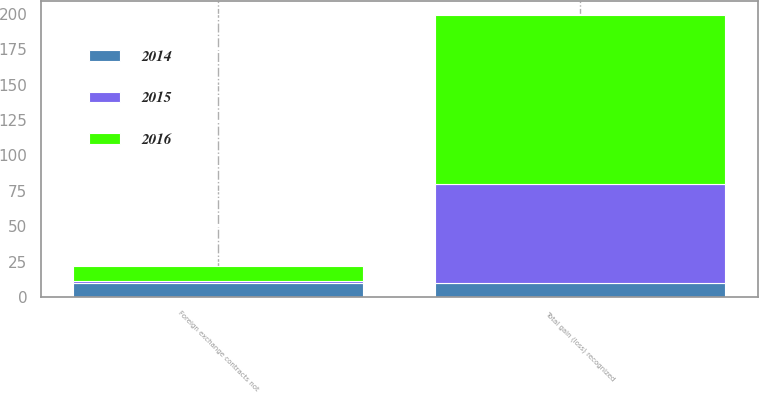<chart> <loc_0><loc_0><loc_500><loc_500><stacked_bar_chart><ecel><fcel>Foreign exchange contracts not<fcel>Total gain (loss) recognized<nl><fcel>2016<fcel>11<fcel>119<nl><fcel>2015<fcel>1<fcel>70<nl><fcel>2014<fcel>10<fcel>10<nl></chart> 